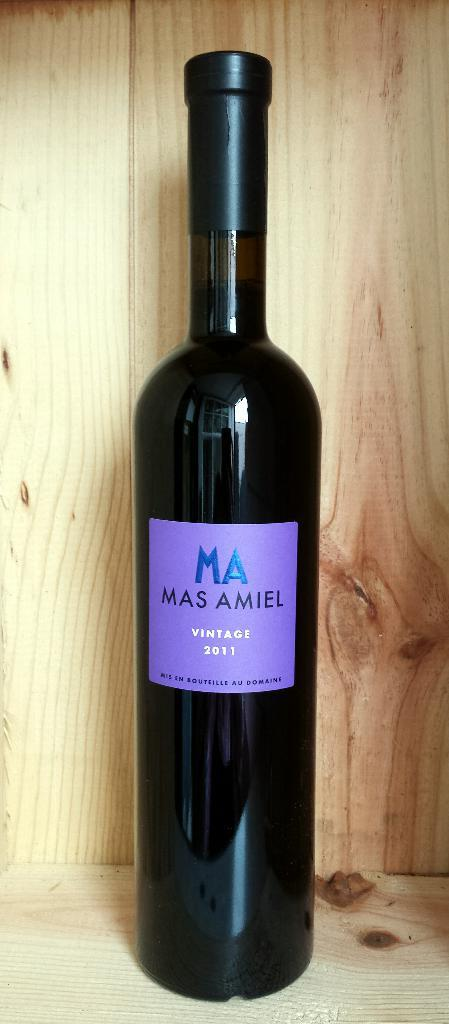<image>
Offer a succinct explanation of the picture presented. A bottle of wine with the words Mas Amiel on the label. 